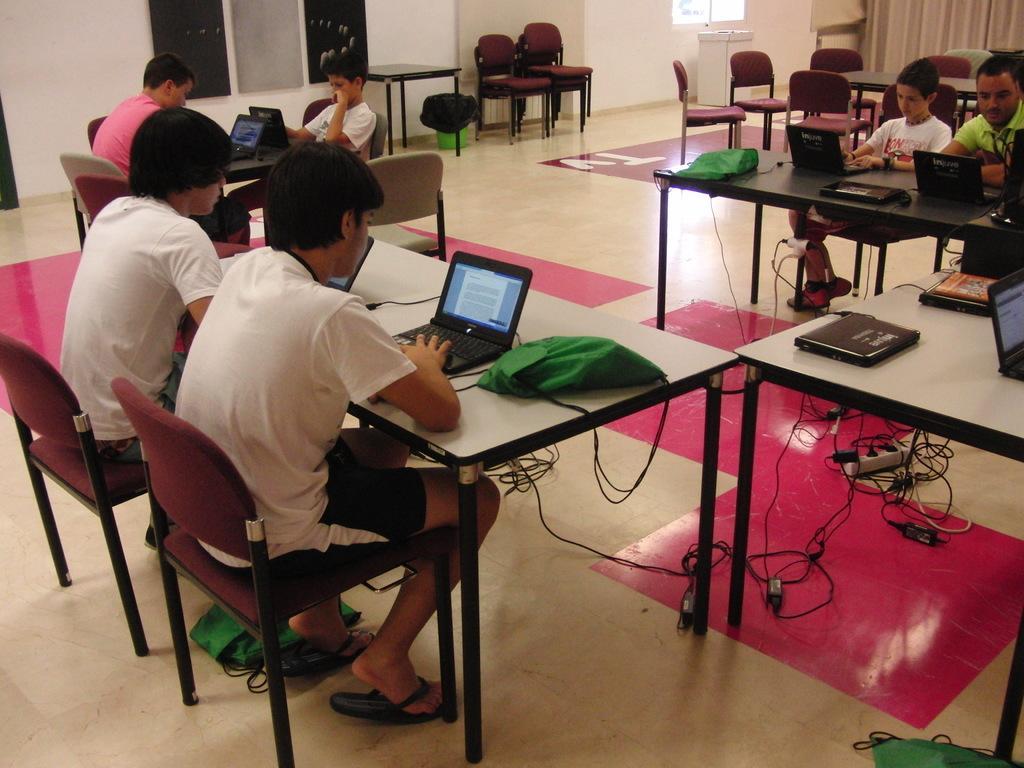Describe this image in one or two sentences. In this image I see 6 persons and all of them are sitting, I can also see that there are lot of tables and chairs and there are laptops on the tables. In the background I can see the wall and the window. 